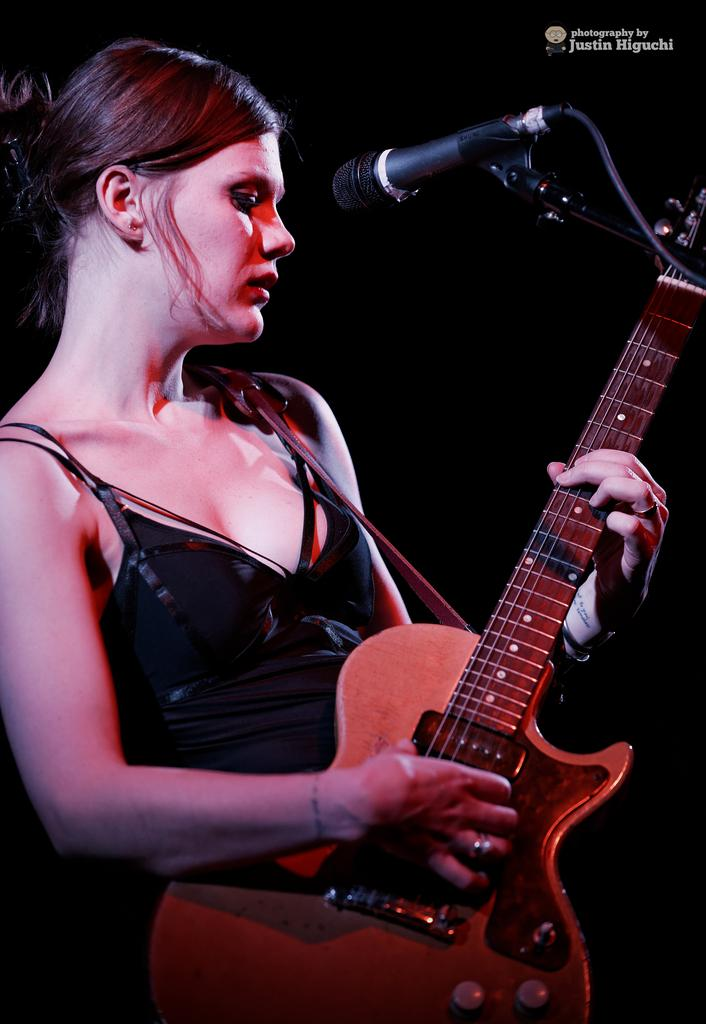Who is the main subject in the image? There is a lady in the center of the image. What is the lady holding in the image? The lady is holding a guitar. What object is in front of the lady? There is a microphone in front of the lady. What type of camera can be seen in the image? There is no camera present in the image. What is the lady's theory about the copper industry? The image does not provide any information about the lady's theories or opinions on the copper industry. 